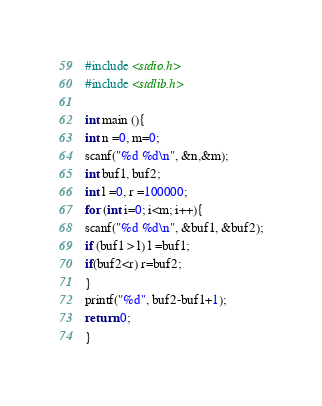Convert code to text. <code><loc_0><loc_0><loc_500><loc_500><_C_>#include <stdio.h>
#include <stdlib.h>

int main (){
int n =0, m=0;
scanf("%d %d\n", &n,&m);
int buf1, buf2;
int l =0, r =100000;
for (int i=0; i<m; i++){
scanf("%d %d\n", &buf1, &buf2);
if (buf1 > l) l =buf1;
if(buf2<r) r=buf2;
}
printf("%d", buf2-buf1+1);
return 0;
}</code> 